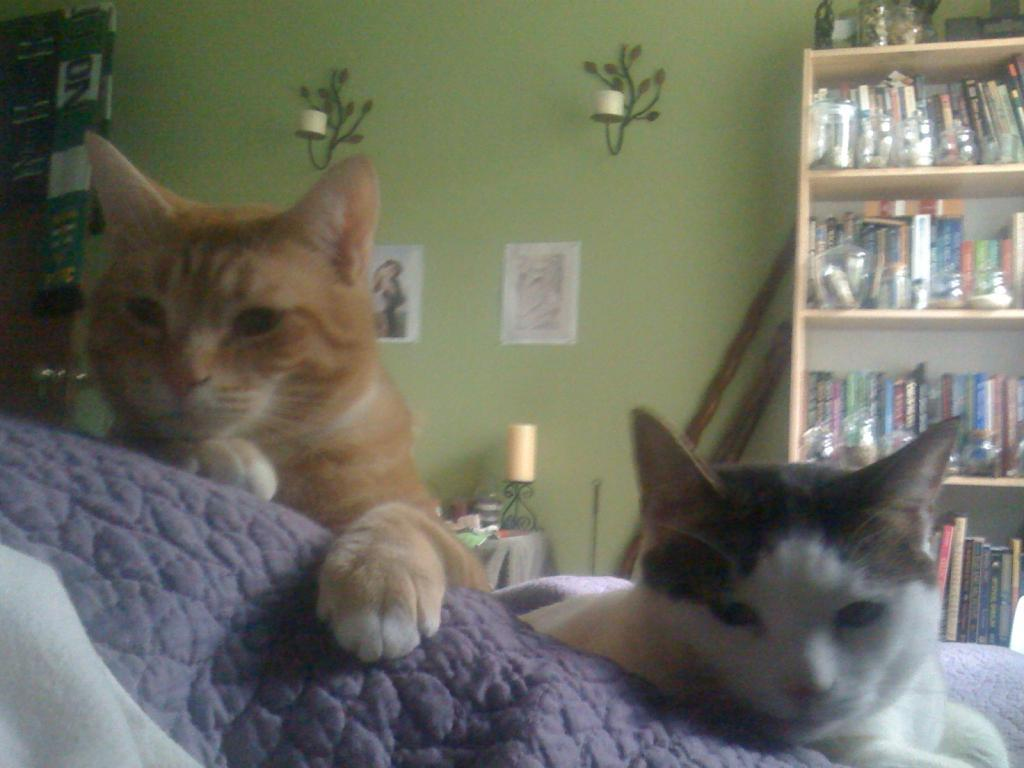What can be seen on the wall in the image? There is a rack filled with books on the wall in the image. What type of objects are on the rack? The rack is filled with books. What animals are present in the image? There are cats in the image. What else can be seen on the table in the image? There are papers on the table in the image. What is the source of light in the image? There is a lamp in the image. What piece of furniture is the rack and books placed on? There is a table in the image. Can you see any tomatoes growing on the wall in the image? There are no tomatoes present in the image; it features a wall with a rack filled with books. Is there a pipe visible in the image? There is no pipe present in the image. 